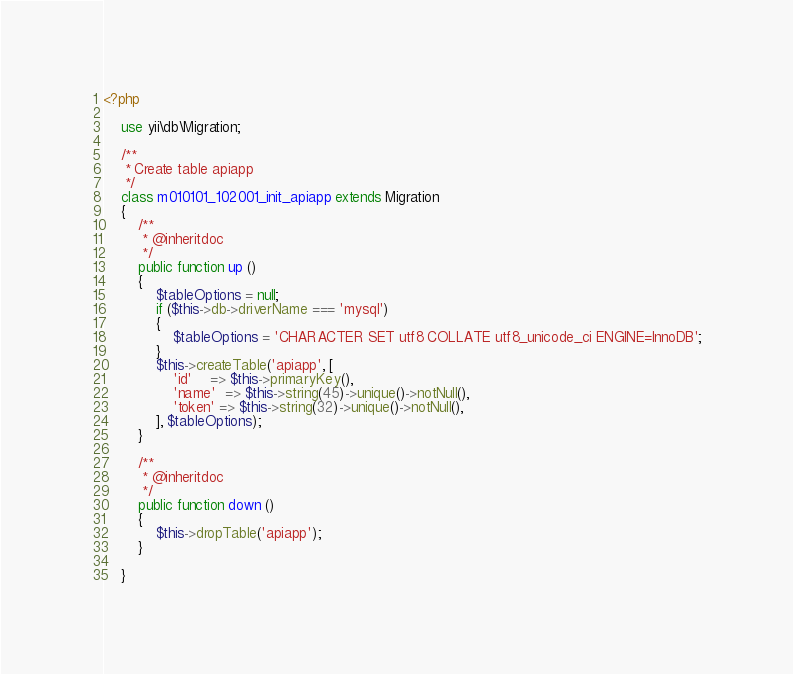Convert code to text. <code><loc_0><loc_0><loc_500><loc_500><_PHP_><?php

	use yii\db\Migration;

	/**
	 * Create table apiapp
	 */
	class m010101_102001_init_apiapp extends Migration
	{
		/**
		 * @inheritdoc
		 */
		public function up ()
		{
			$tableOptions = null;
			if ($this->db->driverName === 'mysql')
			{
				$tableOptions = 'CHARACTER SET utf8 COLLATE utf8_unicode_ci ENGINE=InnoDB';
			}
			$this->createTable('apiapp', [
				'id'    => $this->primaryKey(),
				'name'  => $this->string(45)->unique()->notNull(),
				'token' => $this->string(32)->unique()->notNull(),
			], $tableOptions);
		}

		/**
		 * @inheritdoc
		 */
		public function down ()
		{
			$this->dropTable('apiapp');
		}

	}</code> 